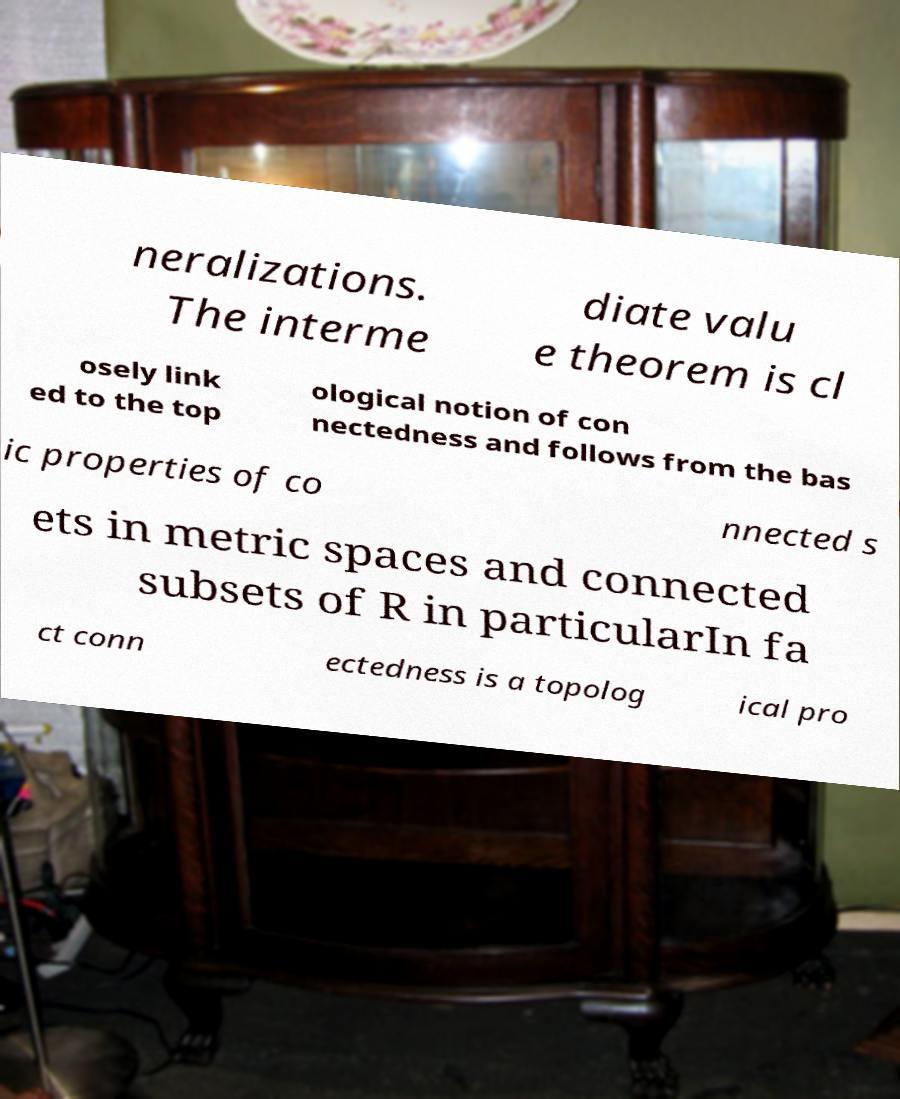Can you read and provide the text displayed in the image?This photo seems to have some interesting text. Can you extract and type it out for me? neralizations. The interme diate valu e theorem is cl osely link ed to the top ological notion of con nectedness and follows from the bas ic properties of co nnected s ets in metric spaces and connected subsets of R in particularIn fa ct conn ectedness is a topolog ical pro 